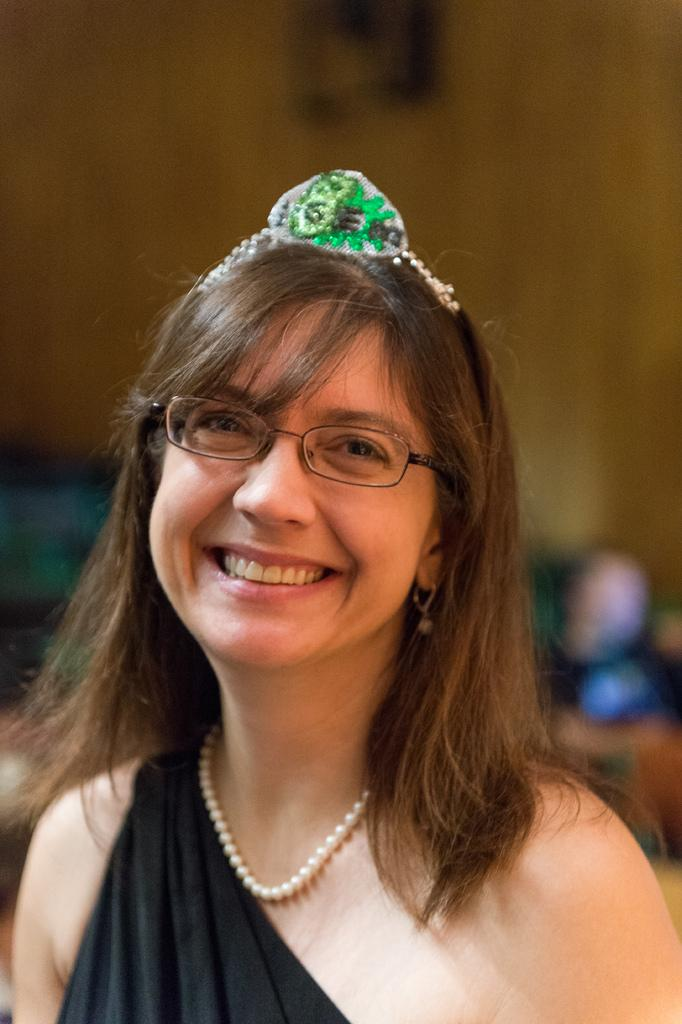What is the main subject of the image? The main subject of the image is a woman. Can you describe the woman's attire? The woman is wearing a black dress. What is the woman's facial expression in the image? The woman is smiling. What is the woman doing in the image? The woman is giving a pose for the picture. What is on the woman's head in the image? There is a crown on the woman's head. What can be seen in the background of the image? There is a wall in the background of the image. Reasoning: Let' Let's think step by step in order to produce the conversation. We start by identifying the main subject of the image, which is the woman. Then, we describe her attire, facial expression, and actions in the image. We also mention the presence of a crown on her head and a wall in the background. Each question is designed to elicit a specific detail about the image that is known from the provided facts. Absurd Question/Answer: What type of meat can be seen in the woman's hand in the image? There is no meat present in the image; the woman is wearing a crown and giving a pose for the picture. Why is the woman crying in the image? The woman is not crying in the image; she is smiling and giving a pose for the picture. What type of acoustics can be heard in the image? There is no sound or acoustics present in the image; it is a still photograph of a woman wearing a crown and giving a pose for the picture. 